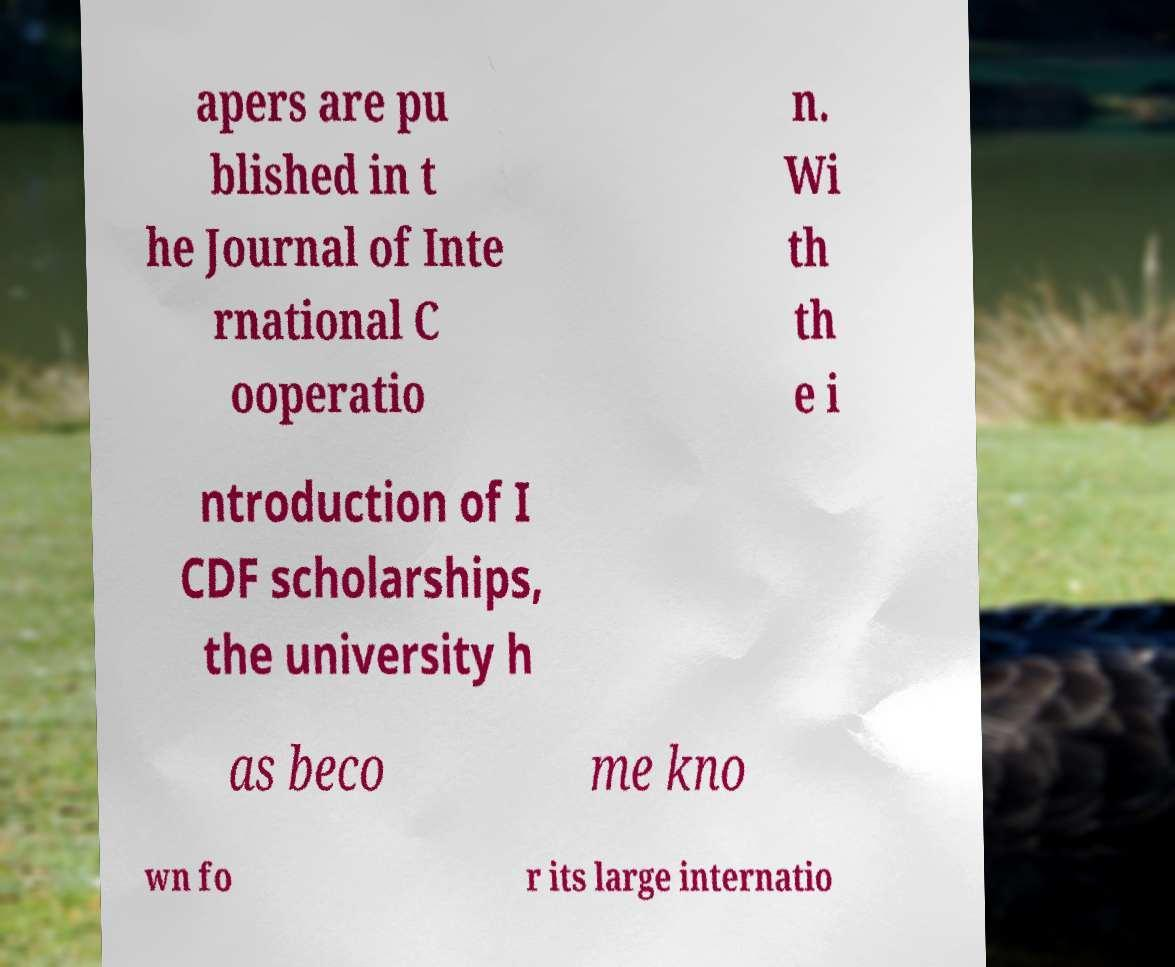For documentation purposes, I need the text within this image transcribed. Could you provide that? apers are pu blished in t he Journal of Inte rnational C ooperatio n. Wi th th e i ntroduction of I CDF scholarships, the university h as beco me kno wn fo r its large internatio 